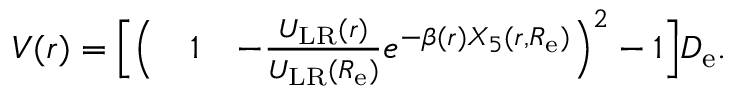Convert formula to latex. <formula><loc_0><loc_0><loc_500><loc_500>\begin{array} { r l r } { V ( r ) = \left [ \left ( } & 1 } & { - \frac { U _ { L R } ( r ) } { U _ { L R } ( R _ { e } ) } e ^ { - \beta ( r ) X _ { 5 } ( r , R _ { e } ) } \right ) ^ { 2 } - 1 \right ] D _ { e } . } \end{array}</formula> 